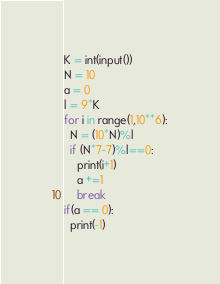<code> <loc_0><loc_0><loc_500><loc_500><_Python_>K = int(input())
N = 10
a = 0
l = 9*K
for i in range(1,10**6):
  N = (10*N)%l
  if (N*7-7)%l==0:
    print(i+1)
    a +=1
    break
if(a == 0):
  print(-1)</code> 